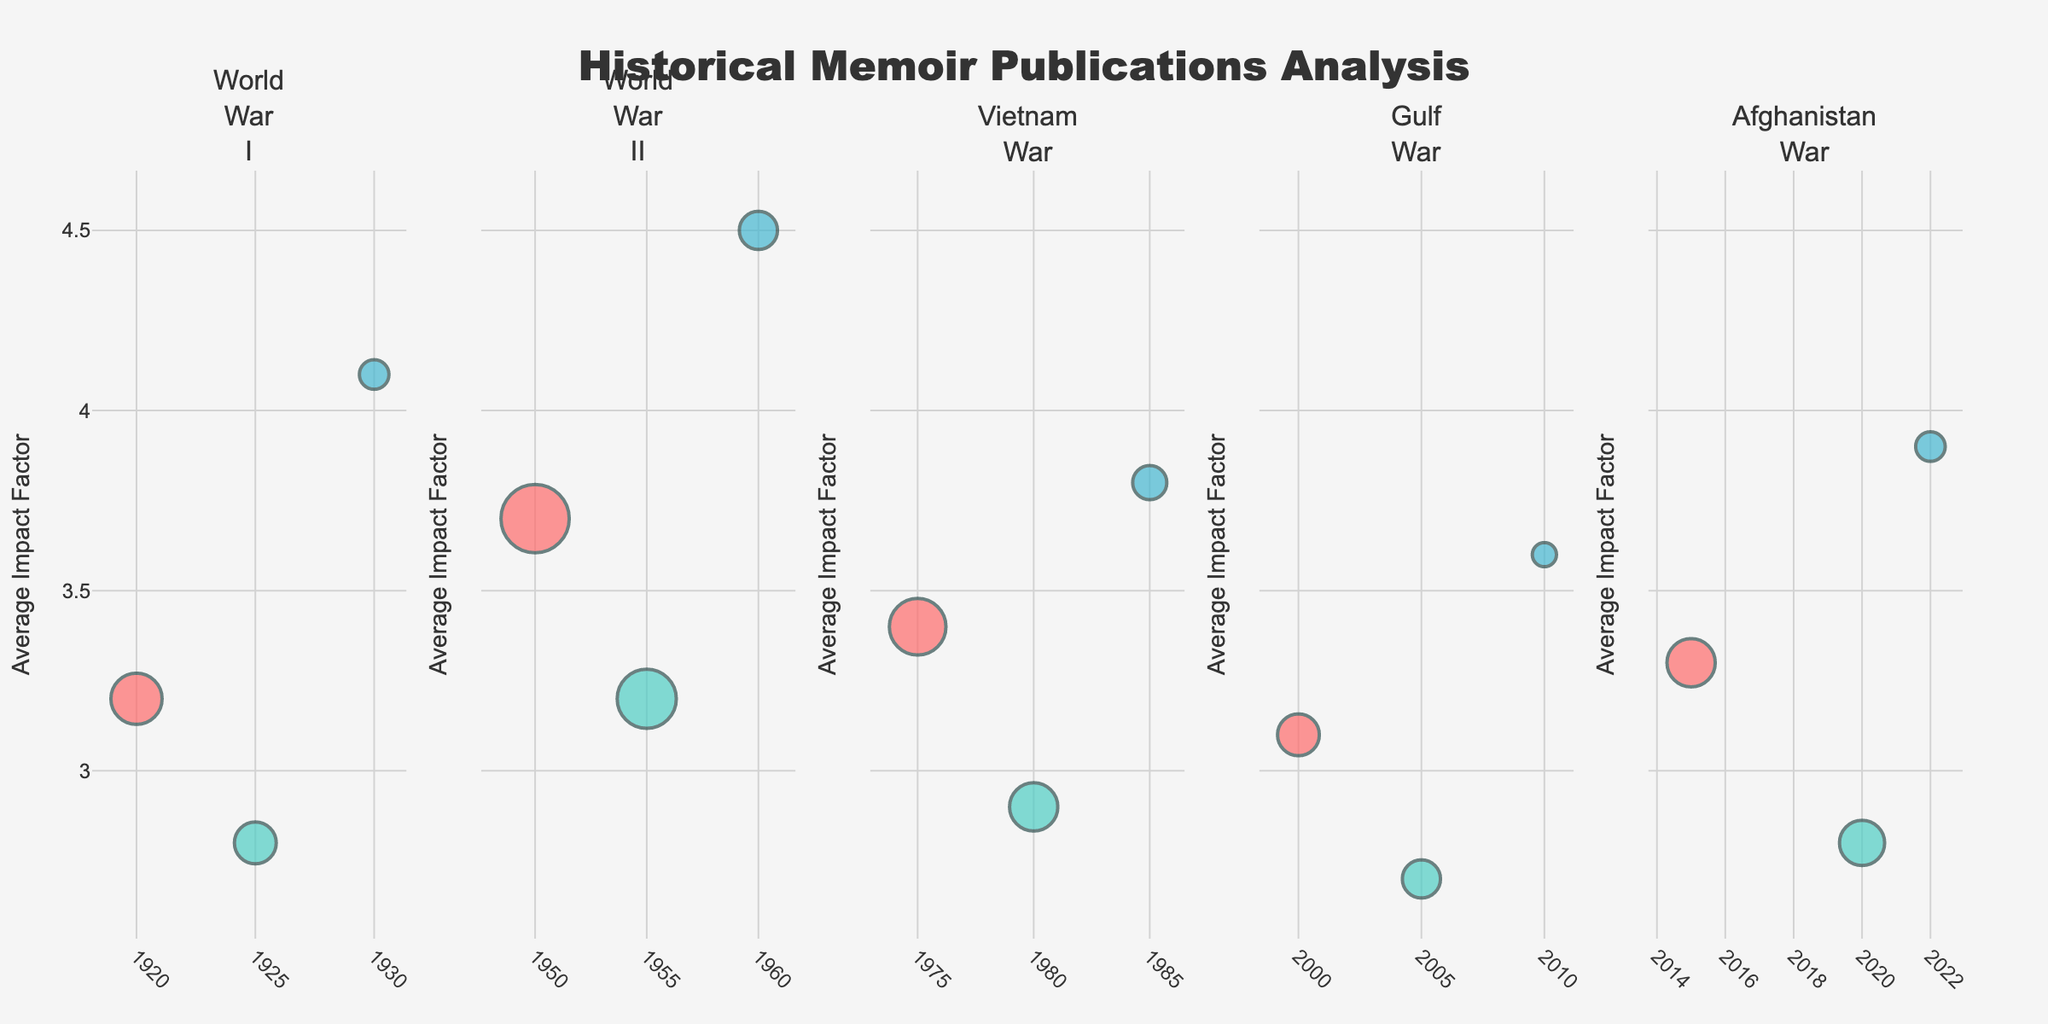How many subplots are there in the figure? The figure is divided based on different wars/conflicts. There are subplots for World War I, World War II, Vietnam War, Gulf War, and Afghanistan War, making a total of 5 subplots.
Answer: 5 Which author's role is represented using the reddish-colored bubbles? The reddish-colored bubbles are used to represent soldiers across the different subplots.
Answer: Soldier What is the title of the y-axis? The title of the y-axis is "Average Impact Factor."
Answer: Average Impact Factor Between which years did the publications related to the Vietnam War appear? Looking at the subplot for the Vietnam War, the publications span between the years 1975 and 1985.
Answer: 1975-1985 What is the highest average impact factor recorded in the Afghanistan War subplot? The highest average impact factor for the Afghanistan War is represented by the Politician role, with a value of 3.9.
Answer: 3.9 Which war/conflict has the highest number of publications by soldiers? In the subplot for World War II, soldiers have the highest number of publications at 80, represented by the largest bubble.
Answer: World War II How does the average impact factor for civilian publications in the Gulf War compare to those in the Vietnam War? Civilian publications in the Gulf War have an average impact factor of 2.7, while those in the Vietnam War have an average impact factor of 2.9.
Answer: Gulf War: 2.7, Vietnam War: 2.9 What is the difference in the number of publications between World War I soldiers and World War II soldiers? In World War I, soldiers have 45 publications, while in World War II, soldiers have 80 publications. The difference is 80 - 45 = 35.
Answer: 35 Which author's role has the most consistent average impact factor across all wars/conflicts? Politicians appear to have the most consistent average impact factor across all wars/conflicts, staying around the range of 3.6 to 4.5.
Answer: Politicians 